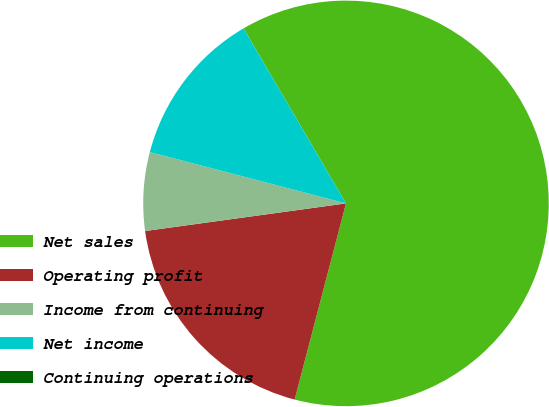Convert chart to OTSL. <chart><loc_0><loc_0><loc_500><loc_500><pie_chart><fcel>Net sales<fcel>Operating profit<fcel>Income from continuing<fcel>Net income<fcel>Continuing operations<nl><fcel>62.5%<fcel>18.75%<fcel>6.25%<fcel>12.5%<fcel>0.0%<nl></chart> 